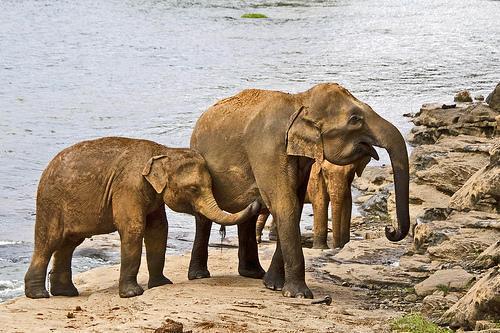How many elephants are visible?
Give a very brief answer. 3. 